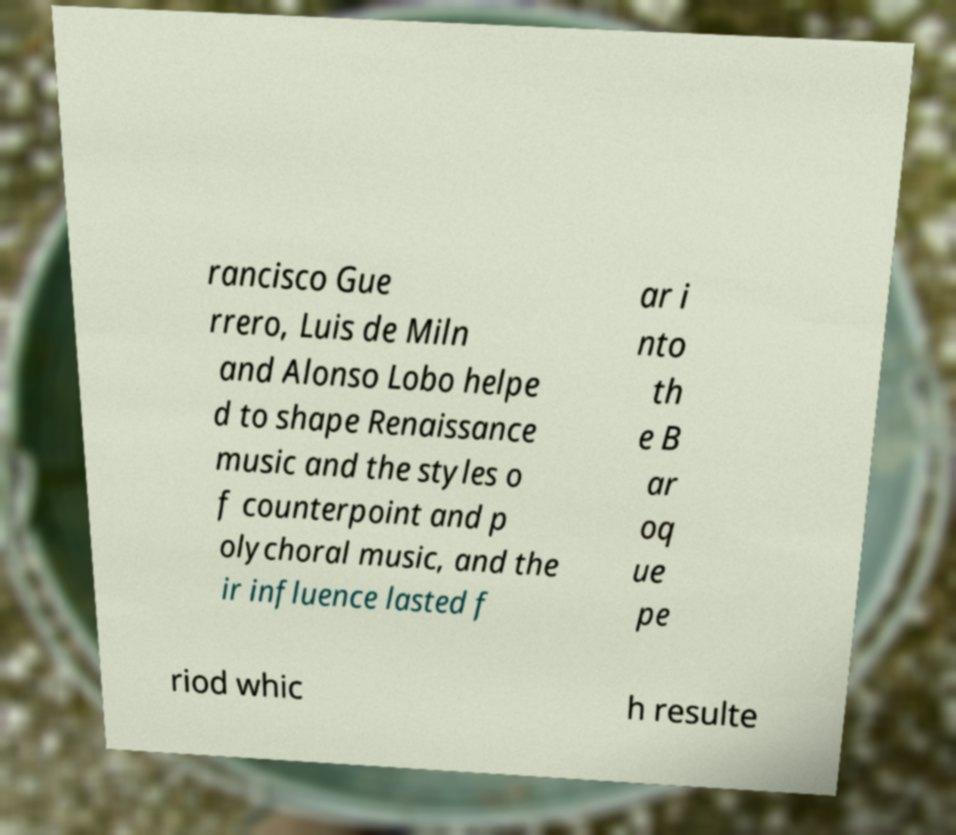Can you accurately transcribe the text from the provided image for me? rancisco Gue rrero, Luis de Miln and Alonso Lobo helpe d to shape Renaissance music and the styles o f counterpoint and p olychoral music, and the ir influence lasted f ar i nto th e B ar oq ue pe riod whic h resulte 